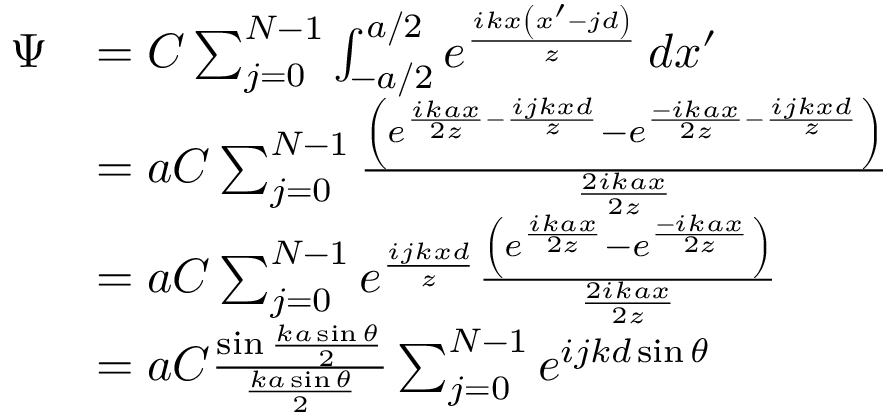<formula> <loc_0><loc_0><loc_500><loc_500>{ \begin{array} { r l } { \Psi } & { = C \sum _ { j = 0 } ^ { N - 1 } \int _ { - { a } / { 2 } } ^ { { a } / { 2 } } e ^ { \frac { i k x \left ( x ^ { \prime } - j d \right ) } { z } } \, d x ^ { \prime } } \\ & { = a C \sum _ { j = 0 } ^ { N - 1 } { \frac { \left ( e ^ { { \frac { i k a x } { 2 z } } - { \frac { i j k x d } { z } } } - e ^ { { \frac { - i k a x } { 2 z } } - { \frac { i j k x d } { z } } } \right ) } { \frac { 2 i k a x } { 2 z } } } } \\ & { = a C \sum _ { j = 0 } ^ { N - 1 } e ^ { \frac { i j k x d } { z } } { \frac { \left ( e ^ { \frac { i k a x } { 2 z } } - e ^ { \frac { - i k a x } { 2 z } } \right ) } { \frac { 2 i k a x } { 2 z } } } } \\ & { = a C { \frac { \sin { \frac { k a \sin \theta } { 2 } } } { \frac { k a \sin \theta } { 2 } } } \sum _ { j = 0 } ^ { N - 1 } e ^ { i j k d \sin \theta } } \end{array} }</formula> 